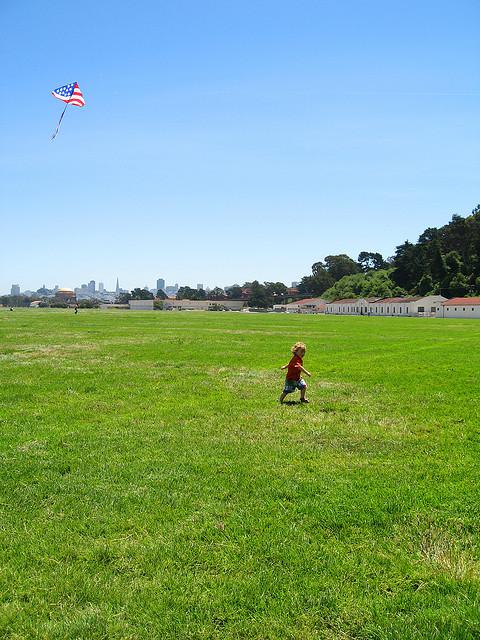Has the field been mowed recently?
Be succinct. Yes. How many kites are flying?
Answer briefly. 1. What is the child doing?
Write a very short answer. Flying kite. 